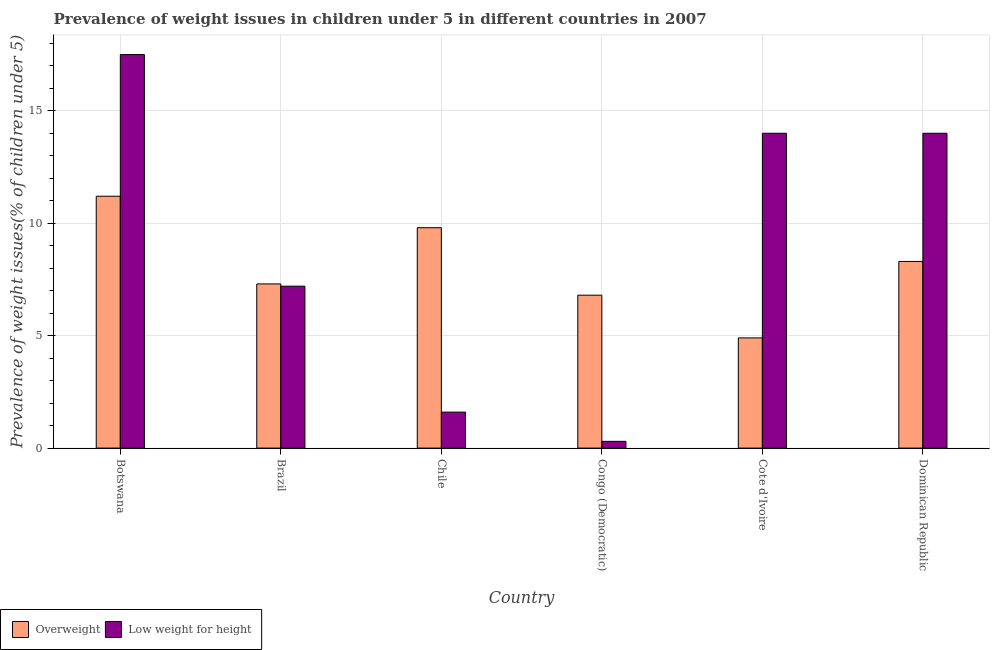Are the number of bars per tick equal to the number of legend labels?
Ensure brevity in your answer.  Yes. How many bars are there on the 1st tick from the right?
Offer a terse response. 2. What is the label of the 1st group of bars from the left?
Keep it short and to the point. Botswana. In how many cases, is the number of bars for a given country not equal to the number of legend labels?
Provide a short and direct response. 0. What is the percentage of overweight children in Brazil?
Give a very brief answer. 7.3. Across all countries, what is the maximum percentage of overweight children?
Give a very brief answer. 11.2. Across all countries, what is the minimum percentage of underweight children?
Your answer should be compact. 0.3. In which country was the percentage of underweight children maximum?
Keep it short and to the point. Botswana. In which country was the percentage of overweight children minimum?
Your answer should be very brief. Cote d'Ivoire. What is the total percentage of overweight children in the graph?
Offer a very short reply. 48.3. What is the difference between the percentage of overweight children in Botswana and that in Chile?
Offer a very short reply. 1.4. What is the difference between the percentage of overweight children in Congo (Democratic) and the percentage of underweight children in Dominican Republic?
Your response must be concise. -7.2. What is the average percentage of underweight children per country?
Offer a terse response. 9.1. What is the difference between the percentage of underweight children and percentage of overweight children in Cote d'Ivoire?
Provide a short and direct response. 9.1. What is the ratio of the percentage of underweight children in Brazil to that in Chile?
Your answer should be very brief. 4.5. Is the percentage of underweight children in Botswana less than that in Chile?
Provide a succinct answer. No. What is the difference between the highest and the second highest percentage of overweight children?
Give a very brief answer. 1.4. What is the difference between the highest and the lowest percentage of underweight children?
Give a very brief answer. 17.2. Is the sum of the percentage of underweight children in Chile and Dominican Republic greater than the maximum percentage of overweight children across all countries?
Keep it short and to the point. Yes. What does the 1st bar from the left in Brazil represents?
Make the answer very short. Overweight. What does the 1st bar from the right in Botswana represents?
Provide a short and direct response. Low weight for height. Are all the bars in the graph horizontal?
Make the answer very short. No. Does the graph contain any zero values?
Offer a terse response. No. Does the graph contain grids?
Offer a terse response. Yes. Where does the legend appear in the graph?
Offer a terse response. Bottom left. What is the title of the graph?
Your answer should be very brief. Prevalence of weight issues in children under 5 in different countries in 2007. Does "Mobile cellular" appear as one of the legend labels in the graph?
Keep it short and to the point. No. What is the label or title of the X-axis?
Keep it short and to the point. Country. What is the label or title of the Y-axis?
Your response must be concise. Prevalence of weight issues(% of children under 5). What is the Prevalence of weight issues(% of children under 5) in Overweight in Botswana?
Offer a very short reply. 11.2. What is the Prevalence of weight issues(% of children under 5) of Low weight for height in Botswana?
Provide a succinct answer. 17.5. What is the Prevalence of weight issues(% of children under 5) of Overweight in Brazil?
Your answer should be very brief. 7.3. What is the Prevalence of weight issues(% of children under 5) in Low weight for height in Brazil?
Give a very brief answer. 7.2. What is the Prevalence of weight issues(% of children under 5) in Overweight in Chile?
Your answer should be compact. 9.8. What is the Prevalence of weight issues(% of children under 5) of Low weight for height in Chile?
Make the answer very short. 1.6. What is the Prevalence of weight issues(% of children under 5) in Overweight in Congo (Democratic)?
Your answer should be very brief. 6.8. What is the Prevalence of weight issues(% of children under 5) of Low weight for height in Congo (Democratic)?
Give a very brief answer. 0.3. What is the Prevalence of weight issues(% of children under 5) of Overweight in Cote d'Ivoire?
Offer a very short reply. 4.9. What is the Prevalence of weight issues(% of children under 5) in Low weight for height in Cote d'Ivoire?
Keep it short and to the point. 14. What is the Prevalence of weight issues(% of children under 5) in Overweight in Dominican Republic?
Make the answer very short. 8.3. What is the Prevalence of weight issues(% of children under 5) of Low weight for height in Dominican Republic?
Make the answer very short. 14. Across all countries, what is the maximum Prevalence of weight issues(% of children under 5) of Overweight?
Keep it short and to the point. 11.2. Across all countries, what is the maximum Prevalence of weight issues(% of children under 5) in Low weight for height?
Give a very brief answer. 17.5. Across all countries, what is the minimum Prevalence of weight issues(% of children under 5) in Overweight?
Make the answer very short. 4.9. Across all countries, what is the minimum Prevalence of weight issues(% of children under 5) of Low weight for height?
Keep it short and to the point. 0.3. What is the total Prevalence of weight issues(% of children under 5) of Overweight in the graph?
Your answer should be compact. 48.3. What is the total Prevalence of weight issues(% of children under 5) of Low weight for height in the graph?
Keep it short and to the point. 54.6. What is the difference between the Prevalence of weight issues(% of children under 5) of Low weight for height in Botswana and that in Brazil?
Offer a very short reply. 10.3. What is the difference between the Prevalence of weight issues(% of children under 5) in Low weight for height in Botswana and that in Chile?
Offer a terse response. 15.9. What is the difference between the Prevalence of weight issues(% of children under 5) of Overweight in Botswana and that in Congo (Democratic)?
Give a very brief answer. 4.4. What is the difference between the Prevalence of weight issues(% of children under 5) in Low weight for height in Botswana and that in Congo (Democratic)?
Your response must be concise. 17.2. What is the difference between the Prevalence of weight issues(% of children under 5) of Overweight in Botswana and that in Cote d'Ivoire?
Offer a very short reply. 6.3. What is the difference between the Prevalence of weight issues(% of children under 5) of Overweight in Botswana and that in Dominican Republic?
Your answer should be compact. 2.9. What is the difference between the Prevalence of weight issues(% of children under 5) of Low weight for height in Botswana and that in Dominican Republic?
Offer a terse response. 3.5. What is the difference between the Prevalence of weight issues(% of children under 5) of Low weight for height in Brazil and that in Chile?
Your answer should be compact. 5.6. What is the difference between the Prevalence of weight issues(% of children under 5) of Overweight in Brazil and that in Congo (Democratic)?
Keep it short and to the point. 0.5. What is the difference between the Prevalence of weight issues(% of children under 5) in Overweight in Brazil and that in Dominican Republic?
Provide a short and direct response. -1. What is the difference between the Prevalence of weight issues(% of children under 5) of Low weight for height in Chile and that in Congo (Democratic)?
Provide a short and direct response. 1.3. What is the difference between the Prevalence of weight issues(% of children under 5) in Overweight in Chile and that in Cote d'Ivoire?
Provide a succinct answer. 4.9. What is the difference between the Prevalence of weight issues(% of children under 5) of Low weight for height in Congo (Democratic) and that in Cote d'Ivoire?
Your answer should be very brief. -13.7. What is the difference between the Prevalence of weight issues(% of children under 5) of Low weight for height in Congo (Democratic) and that in Dominican Republic?
Offer a terse response. -13.7. What is the difference between the Prevalence of weight issues(% of children under 5) in Low weight for height in Cote d'Ivoire and that in Dominican Republic?
Keep it short and to the point. 0. What is the difference between the Prevalence of weight issues(% of children under 5) in Overweight in Botswana and the Prevalence of weight issues(% of children under 5) in Low weight for height in Chile?
Offer a terse response. 9.6. What is the difference between the Prevalence of weight issues(% of children under 5) in Overweight in Brazil and the Prevalence of weight issues(% of children under 5) in Low weight for height in Congo (Democratic)?
Make the answer very short. 7. What is the difference between the Prevalence of weight issues(% of children under 5) of Overweight in Brazil and the Prevalence of weight issues(% of children under 5) of Low weight for height in Cote d'Ivoire?
Your response must be concise. -6.7. What is the difference between the Prevalence of weight issues(% of children under 5) of Overweight in Congo (Democratic) and the Prevalence of weight issues(% of children under 5) of Low weight for height in Cote d'Ivoire?
Offer a very short reply. -7.2. What is the average Prevalence of weight issues(% of children under 5) of Overweight per country?
Provide a succinct answer. 8.05. What is the difference between the Prevalence of weight issues(% of children under 5) of Overweight and Prevalence of weight issues(% of children under 5) of Low weight for height in Botswana?
Your answer should be compact. -6.3. What is the difference between the Prevalence of weight issues(% of children under 5) of Overweight and Prevalence of weight issues(% of children under 5) of Low weight for height in Chile?
Offer a terse response. 8.2. What is the difference between the Prevalence of weight issues(% of children under 5) in Overweight and Prevalence of weight issues(% of children under 5) in Low weight for height in Cote d'Ivoire?
Provide a succinct answer. -9.1. What is the difference between the Prevalence of weight issues(% of children under 5) of Overweight and Prevalence of weight issues(% of children under 5) of Low weight for height in Dominican Republic?
Your answer should be compact. -5.7. What is the ratio of the Prevalence of weight issues(% of children under 5) in Overweight in Botswana to that in Brazil?
Provide a short and direct response. 1.53. What is the ratio of the Prevalence of weight issues(% of children under 5) in Low weight for height in Botswana to that in Brazil?
Keep it short and to the point. 2.43. What is the ratio of the Prevalence of weight issues(% of children under 5) in Overweight in Botswana to that in Chile?
Your answer should be compact. 1.14. What is the ratio of the Prevalence of weight issues(% of children under 5) in Low weight for height in Botswana to that in Chile?
Ensure brevity in your answer.  10.94. What is the ratio of the Prevalence of weight issues(% of children under 5) in Overweight in Botswana to that in Congo (Democratic)?
Give a very brief answer. 1.65. What is the ratio of the Prevalence of weight issues(% of children under 5) in Low weight for height in Botswana to that in Congo (Democratic)?
Your answer should be compact. 58.33. What is the ratio of the Prevalence of weight issues(% of children under 5) in Overweight in Botswana to that in Cote d'Ivoire?
Your answer should be very brief. 2.29. What is the ratio of the Prevalence of weight issues(% of children under 5) in Overweight in Botswana to that in Dominican Republic?
Your answer should be very brief. 1.35. What is the ratio of the Prevalence of weight issues(% of children under 5) in Overweight in Brazil to that in Chile?
Provide a short and direct response. 0.74. What is the ratio of the Prevalence of weight issues(% of children under 5) of Overweight in Brazil to that in Congo (Democratic)?
Ensure brevity in your answer.  1.07. What is the ratio of the Prevalence of weight issues(% of children under 5) of Low weight for height in Brazil to that in Congo (Democratic)?
Provide a succinct answer. 24. What is the ratio of the Prevalence of weight issues(% of children under 5) of Overweight in Brazil to that in Cote d'Ivoire?
Provide a short and direct response. 1.49. What is the ratio of the Prevalence of weight issues(% of children under 5) of Low weight for height in Brazil to that in Cote d'Ivoire?
Your response must be concise. 0.51. What is the ratio of the Prevalence of weight issues(% of children under 5) of Overweight in Brazil to that in Dominican Republic?
Make the answer very short. 0.88. What is the ratio of the Prevalence of weight issues(% of children under 5) of Low weight for height in Brazil to that in Dominican Republic?
Your answer should be very brief. 0.51. What is the ratio of the Prevalence of weight issues(% of children under 5) in Overweight in Chile to that in Congo (Democratic)?
Offer a terse response. 1.44. What is the ratio of the Prevalence of weight issues(% of children under 5) of Low weight for height in Chile to that in Congo (Democratic)?
Ensure brevity in your answer.  5.33. What is the ratio of the Prevalence of weight issues(% of children under 5) of Overweight in Chile to that in Cote d'Ivoire?
Make the answer very short. 2. What is the ratio of the Prevalence of weight issues(% of children under 5) in Low weight for height in Chile to that in Cote d'Ivoire?
Ensure brevity in your answer.  0.11. What is the ratio of the Prevalence of weight issues(% of children under 5) in Overweight in Chile to that in Dominican Republic?
Provide a succinct answer. 1.18. What is the ratio of the Prevalence of weight issues(% of children under 5) in Low weight for height in Chile to that in Dominican Republic?
Give a very brief answer. 0.11. What is the ratio of the Prevalence of weight issues(% of children under 5) in Overweight in Congo (Democratic) to that in Cote d'Ivoire?
Ensure brevity in your answer.  1.39. What is the ratio of the Prevalence of weight issues(% of children under 5) in Low weight for height in Congo (Democratic) to that in Cote d'Ivoire?
Keep it short and to the point. 0.02. What is the ratio of the Prevalence of weight issues(% of children under 5) in Overweight in Congo (Democratic) to that in Dominican Republic?
Your response must be concise. 0.82. What is the ratio of the Prevalence of weight issues(% of children under 5) in Low weight for height in Congo (Democratic) to that in Dominican Republic?
Make the answer very short. 0.02. What is the ratio of the Prevalence of weight issues(% of children under 5) in Overweight in Cote d'Ivoire to that in Dominican Republic?
Make the answer very short. 0.59. What is the ratio of the Prevalence of weight issues(% of children under 5) of Low weight for height in Cote d'Ivoire to that in Dominican Republic?
Provide a short and direct response. 1. What is the difference between the highest and the second highest Prevalence of weight issues(% of children under 5) of Low weight for height?
Offer a terse response. 3.5. What is the difference between the highest and the lowest Prevalence of weight issues(% of children under 5) of Overweight?
Offer a terse response. 6.3. 